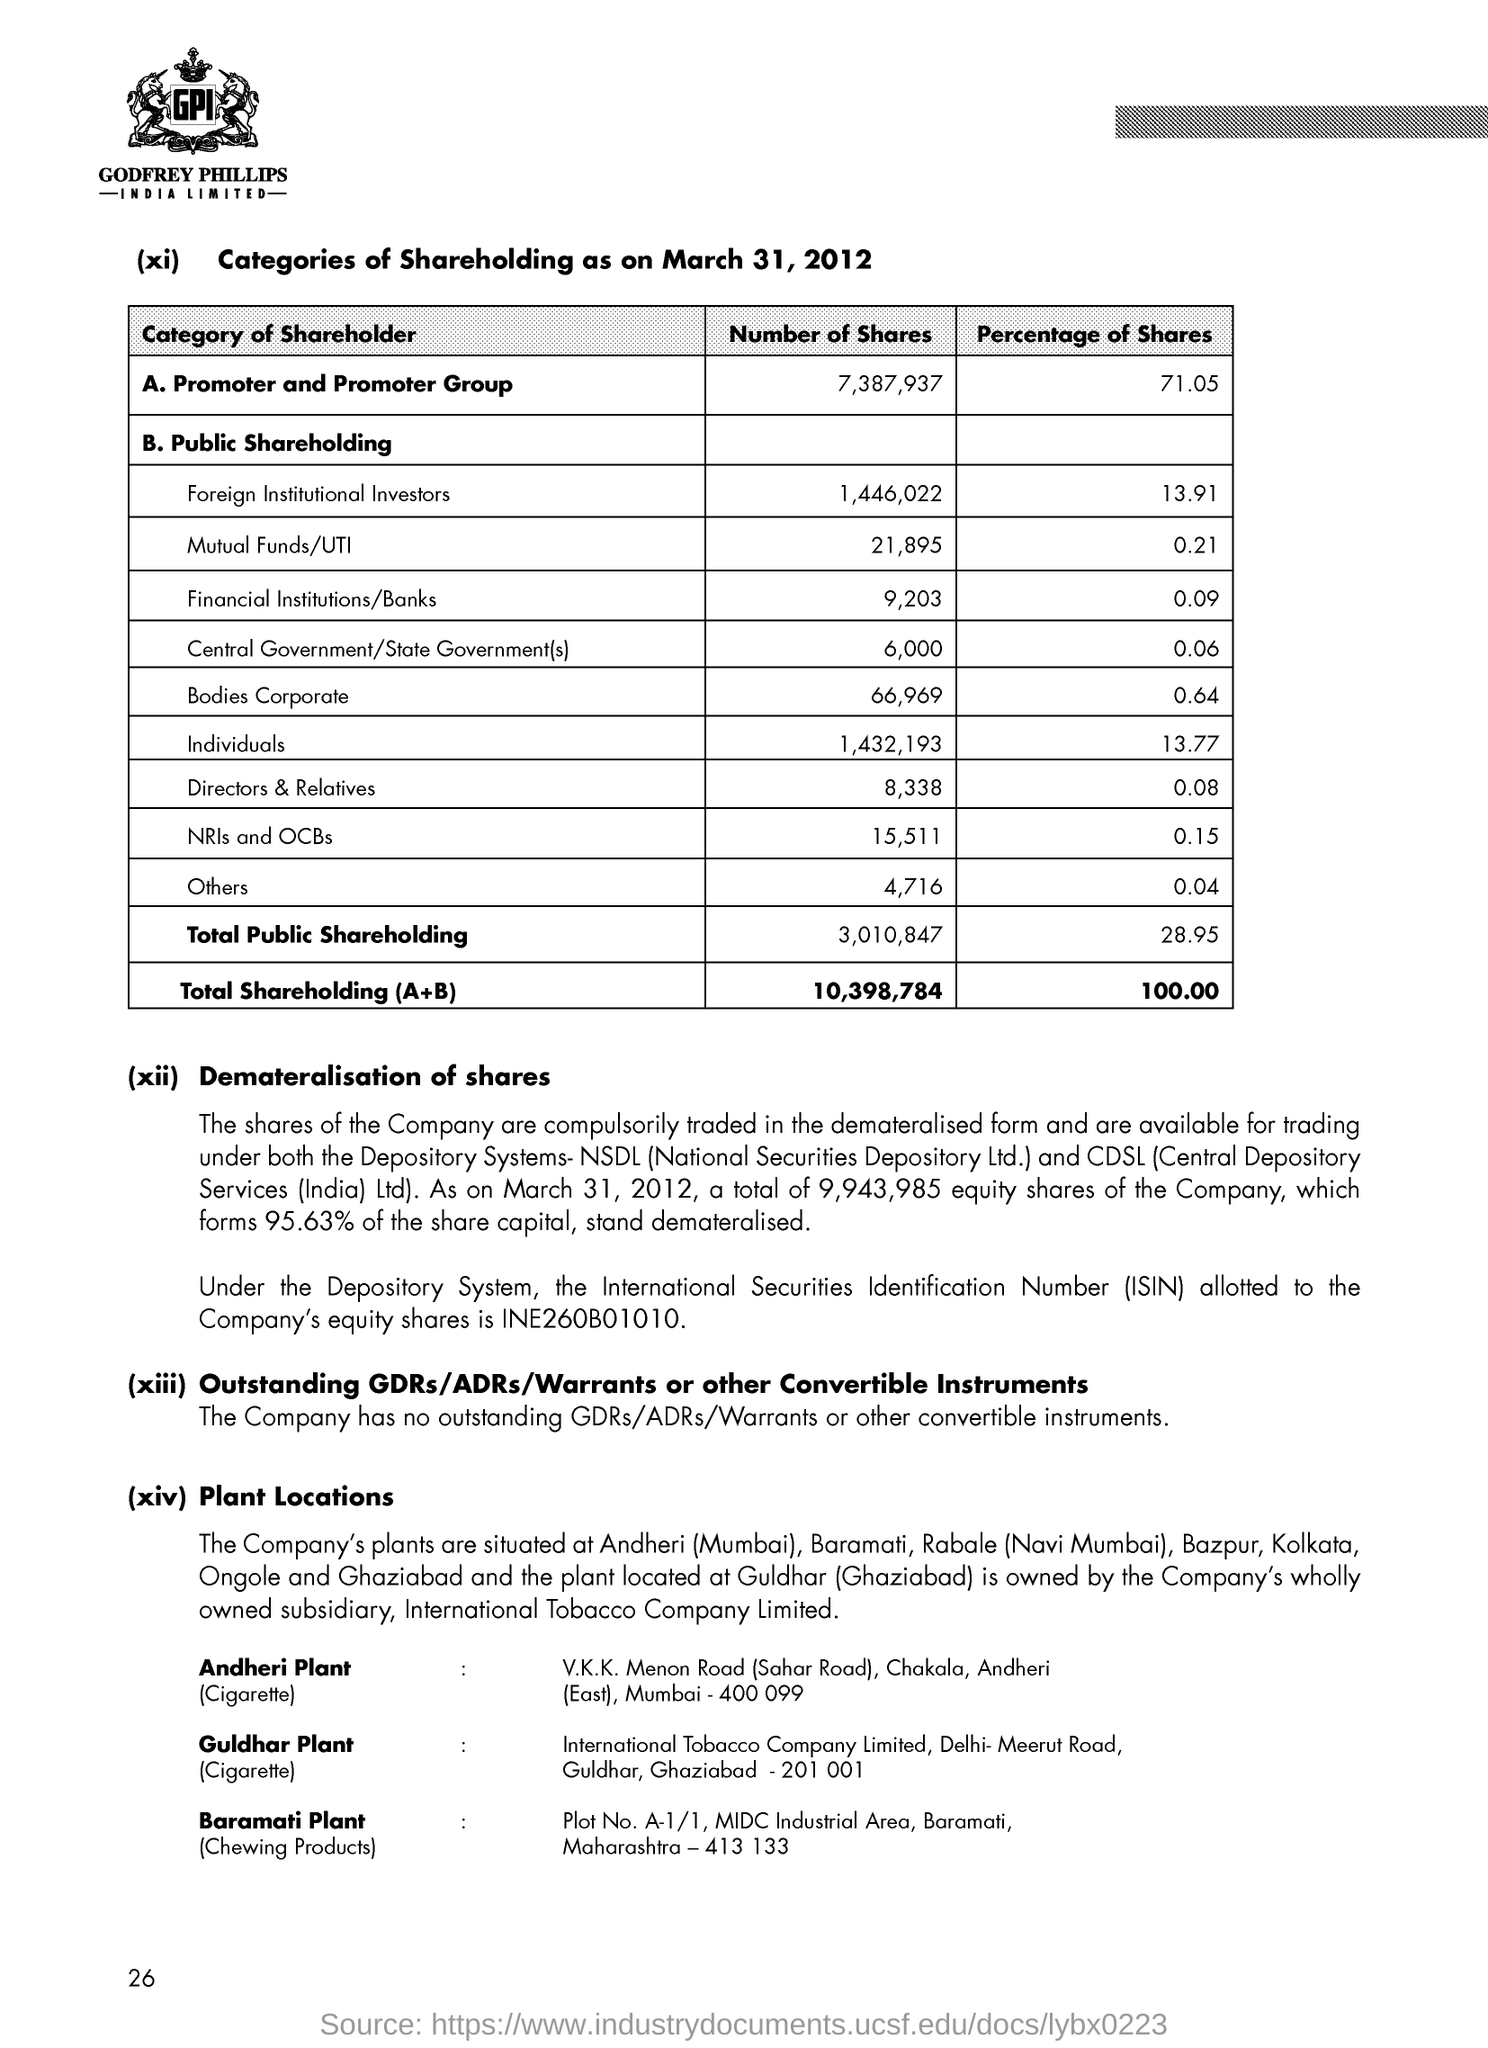Identify some key points in this picture. The percentage of shares for individuals is 13.77%. The image currently displays the logo for Godfrey Phillips India Limited. 